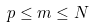<formula> <loc_0><loc_0><loc_500><loc_500>p \leq m \leq N</formula> 